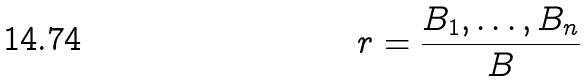<formula> <loc_0><loc_0><loc_500><loc_500>r = \frac { B _ { 1 } , \dots , B _ { n } } { B }</formula> 